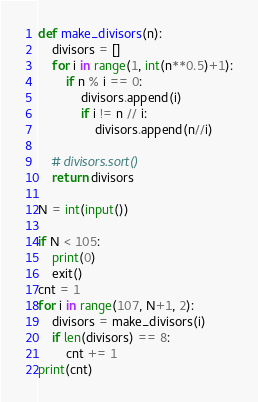<code> <loc_0><loc_0><loc_500><loc_500><_Python_>def make_divisors(n):
    divisors = []
    for i in range(1, int(n**0.5)+1):
        if n % i == 0:
            divisors.append(i)
            if i != n // i:
                divisors.append(n//i)

    # divisors.sort()
    return divisors

N = int(input())

if N < 105:
    print(0)
    exit()
cnt = 1
for i in range(107, N+1, 2):
    divisors = make_divisors(i)
    if len(divisors) == 8:
        cnt += 1
print(cnt)</code> 